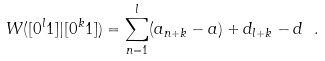Convert formula to latex. <formula><loc_0><loc_0><loc_500><loc_500>W ( [ 0 ^ { l } 1 ] | [ 0 ^ { k } 1 ] ) = \sum _ { n = 1 } ^ { l } ( a _ { n + k } - a ) + d _ { l + k } - d \ .</formula> 